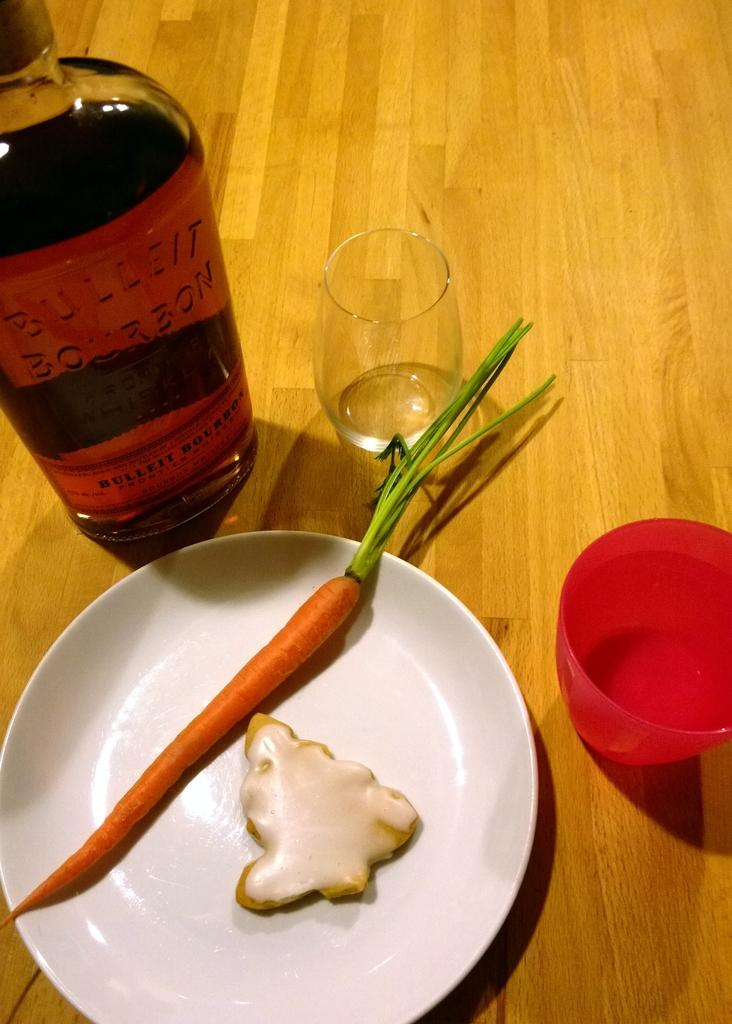<image>
Give a short and clear explanation of the subsequent image. A bottle of Bullet Bourbon is on a table with a carrot and a cookie. 